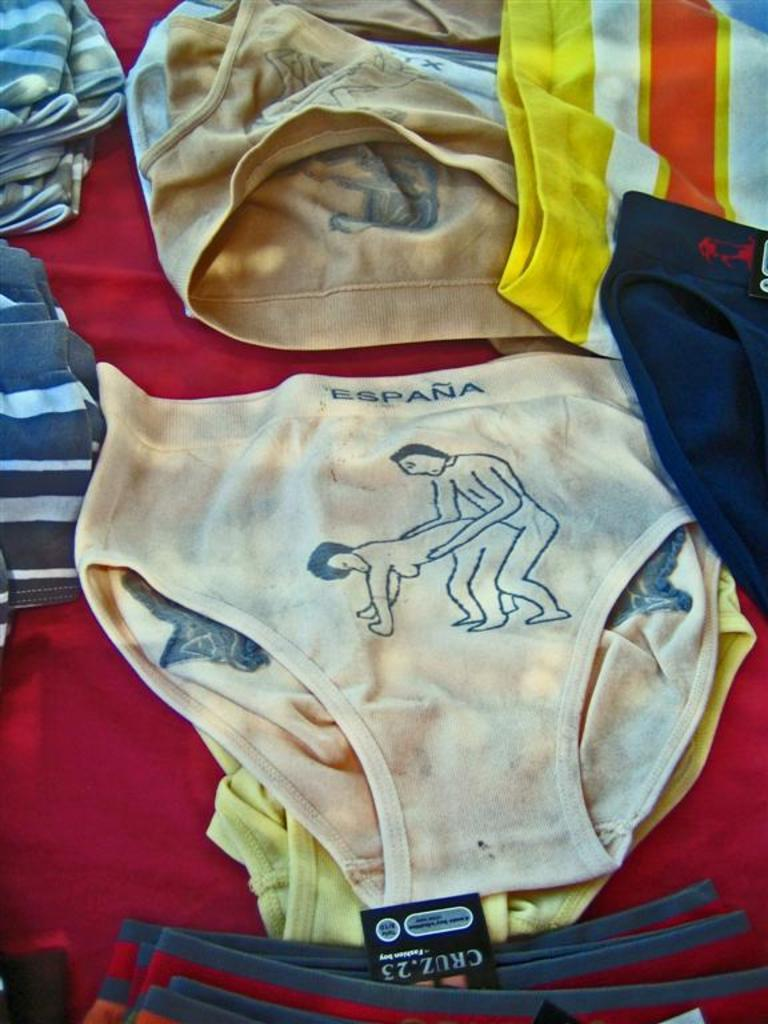<image>
Write a terse but informative summary of the picture. Espana underwear with a man and woman picture and cruz underwear 